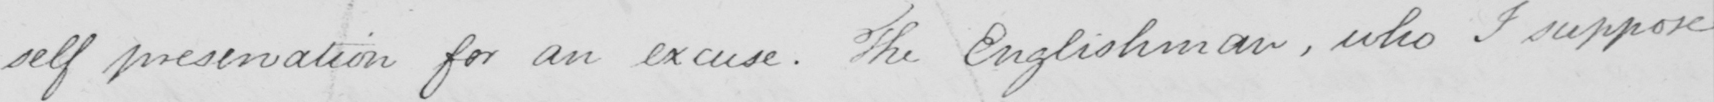Please provide the text content of this handwritten line. self preservation for an excuse . The Englishman , who I suppose 